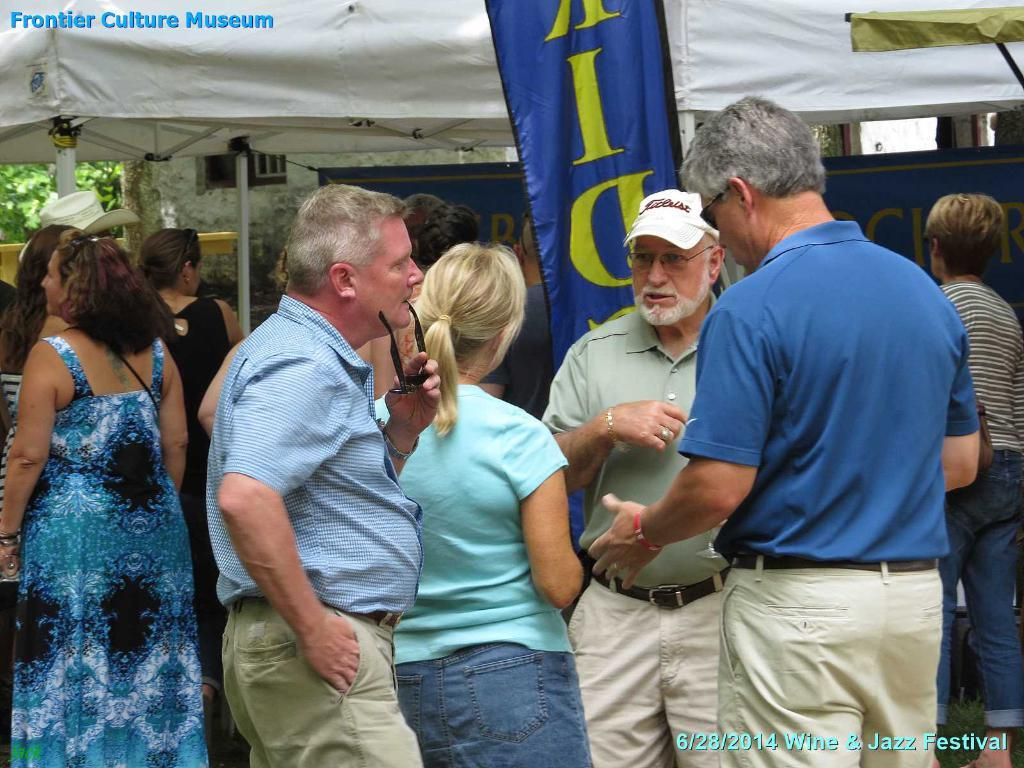How many people are in the image? There is a group of people in the image, but the exact number cannot be determined from the provided facts. What can be seen in the background of the image? In the background of the image, there are banners, a pole, a tent, a wall, and trees. What might the banners be used for? The banners in the background of the image might be used for decoration or to convey information. What color is the plant in the image? There is no plant present in the image, so it is not possible to determine its color. 